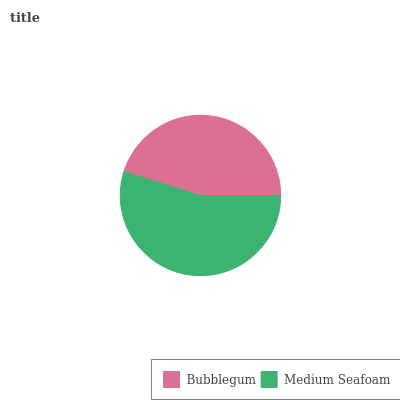Is Bubblegum the minimum?
Answer yes or no. Yes. Is Medium Seafoam the maximum?
Answer yes or no. Yes. Is Medium Seafoam the minimum?
Answer yes or no. No. Is Medium Seafoam greater than Bubblegum?
Answer yes or no. Yes. Is Bubblegum less than Medium Seafoam?
Answer yes or no. Yes. Is Bubblegum greater than Medium Seafoam?
Answer yes or no. No. Is Medium Seafoam less than Bubblegum?
Answer yes or no. No. Is Medium Seafoam the high median?
Answer yes or no. Yes. Is Bubblegum the low median?
Answer yes or no. Yes. Is Bubblegum the high median?
Answer yes or no. No. Is Medium Seafoam the low median?
Answer yes or no. No. 